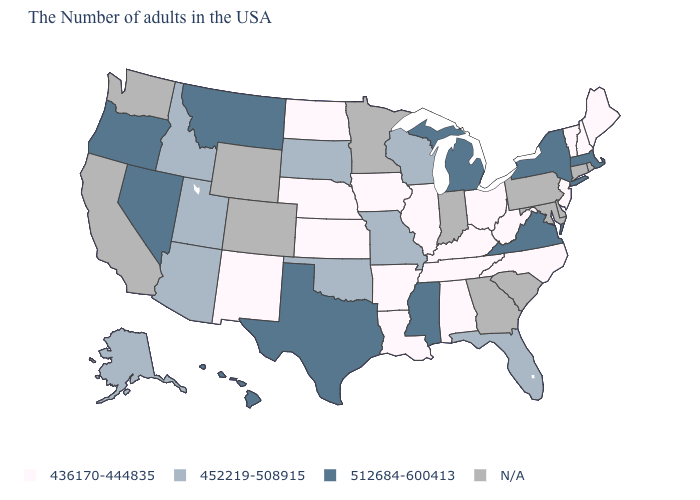Name the states that have a value in the range N/A?
Give a very brief answer. Rhode Island, Connecticut, Delaware, Maryland, Pennsylvania, South Carolina, Georgia, Indiana, Minnesota, Wyoming, Colorado, California, Washington. What is the value of Nevada?
Be succinct. 512684-600413. What is the value of North Dakota?
Give a very brief answer. 436170-444835. What is the value of Massachusetts?
Write a very short answer. 512684-600413. What is the value of Arkansas?
Give a very brief answer. 436170-444835. What is the value of Oklahoma?
Quick response, please. 452219-508915. What is the lowest value in the USA?
Short answer required. 436170-444835. How many symbols are there in the legend?
Be succinct. 4. Name the states that have a value in the range 452219-508915?
Give a very brief answer. Florida, Wisconsin, Missouri, Oklahoma, South Dakota, Utah, Arizona, Idaho, Alaska. Among the states that border Pennsylvania , which have the lowest value?
Keep it brief. New Jersey, West Virginia, Ohio. What is the lowest value in the USA?
Write a very short answer. 436170-444835. Among the states that border Massachusetts , which have the lowest value?
Concise answer only. New Hampshire, Vermont. What is the highest value in the South ?
Keep it brief. 512684-600413. What is the value of Ohio?
Be succinct. 436170-444835. 